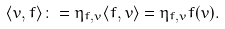Convert formula to latex. <formula><loc_0><loc_0><loc_500><loc_500>\langle v , f \rangle \colon = \eta _ { f , v } \langle f , v \rangle = \eta _ { f , v } f ( v ) .</formula> 